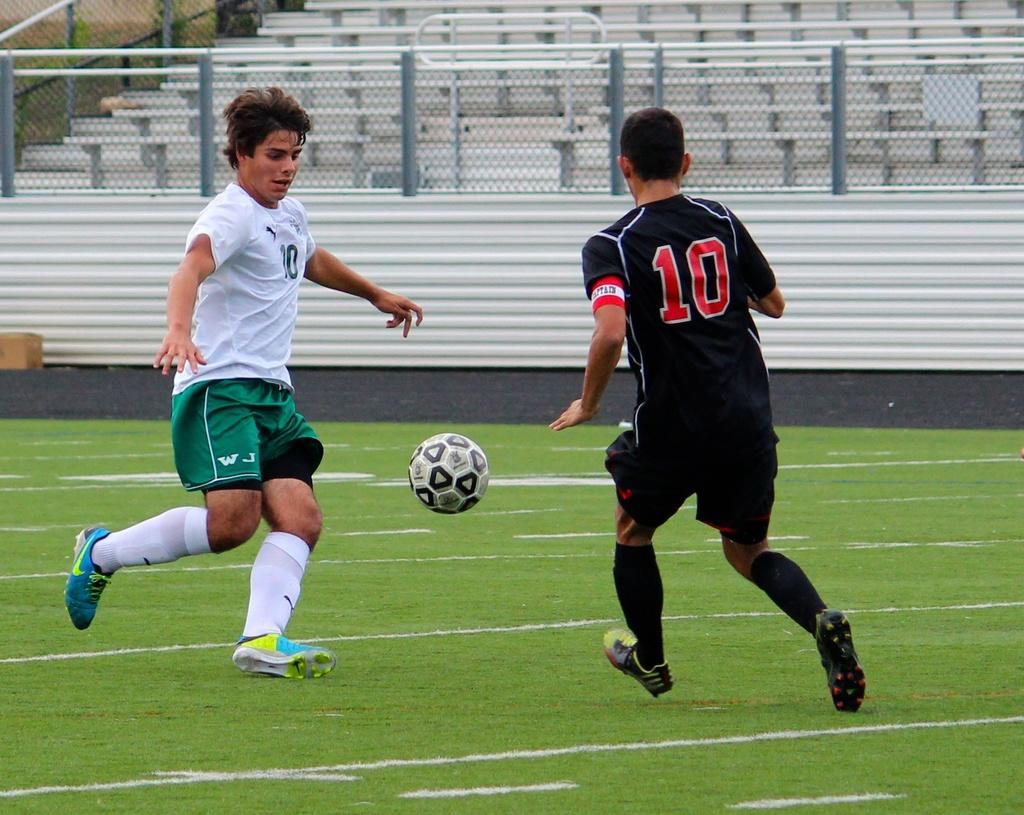What is the main object in the center of the image? There is a ball in the center of the image. What are the two persons in the image doing? The two persons are running in the image. What can be seen in the background of the image? There are fences and chairs in the background of the image. Is there any snow visible in the image? No, there is no snow present in the image. Can you see a cat playing with the ball in the image? No, there is no cat present in the image; only the ball and two running persons are visible. 